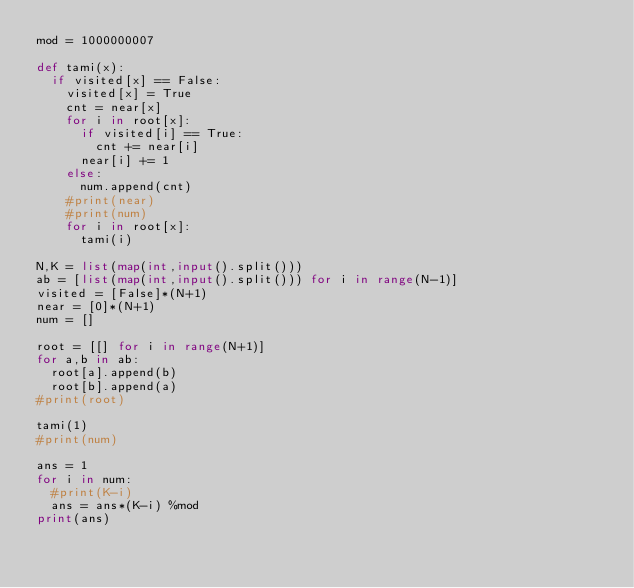Convert code to text. <code><loc_0><loc_0><loc_500><loc_500><_Python_>mod = 1000000007

def tami(x):
  if visited[x] == False:
    visited[x] = True
    cnt = near[x]
    for i in root[x]:
      if visited[i] == True:
        cnt += near[i]
      near[i] += 1
    else:
      num.append(cnt)
    #print(near)
    #print(num)
    for i in root[x]:
      tami(i)

N,K = list(map(int,input().split()))
ab = [list(map(int,input().split())) for i in range(N-1)]
visited = [False]*(N+1)
near = [0]*(N+1)
num = []

root = [[] for i in range(N+1)]
for a,b in ab:
  root[a].append(b)
  root[b].append(a)
#print(root)

tami(1)
#print(num)

ans = 1
for i in num:
  #print(K-i)
  ans = ans*(K-i) %mod
print(ans)</code> 